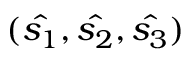<formula> <loc_0><loc_0><loc_500><loc_500>( \hat { s _ { 1 } } , \hat { s _ { 2 } } , \hat { s _ { 3 } } )</formula> 